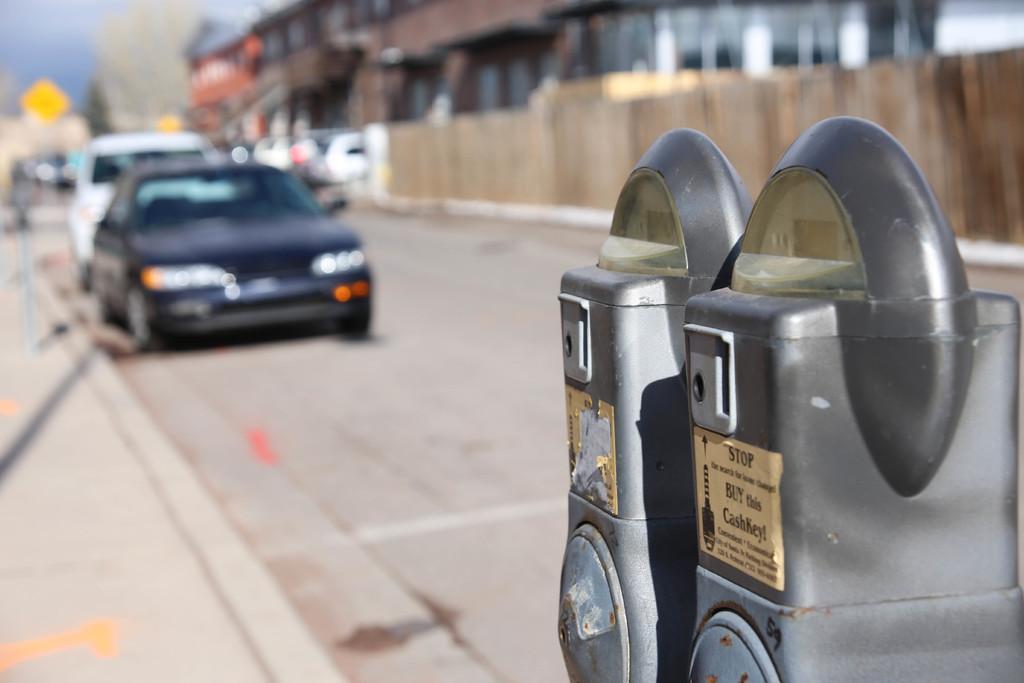How would you summarize this image in a sentence or two? In this picture we can see some vehicles here, on the right side there is a parking machine here, we can see buildings in the background. 